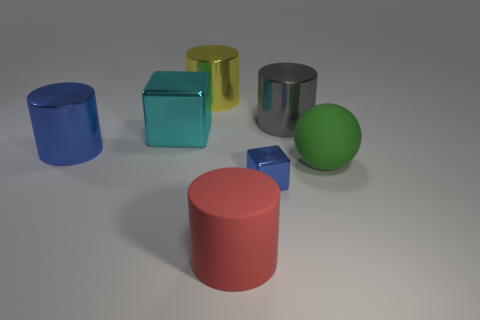Subtract 1 cylinders. How many cylinders are left? 3 Add 2 large gray objects. How many objects exist? 9 Subtract all cylinders. How many objects are left? 3 Add 6 large shiny balls. How many large shiny balls exist? 6 Subtract 0 green cylinders. How many objects are left? 7 Subtract all gray balls. Subtract all green rubber objects. How many objects are left? 6 Add 3 big red objects. How many big red objects are left? 4 